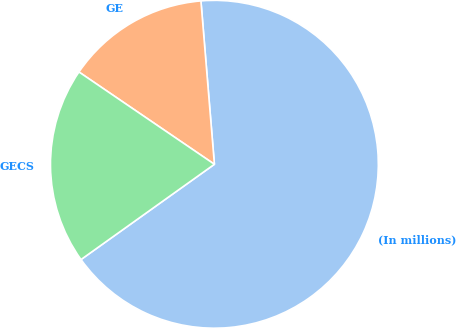Convert chart to OTSL. <chart><loc_0><loc_0><loc_500><loc_500><pie_chart><fcel>(In millions)<fcel>GE<fcel>GECS<nl><fcel>66.44%<fcel>14.17%<fcel>19.39%<nl></chart> 